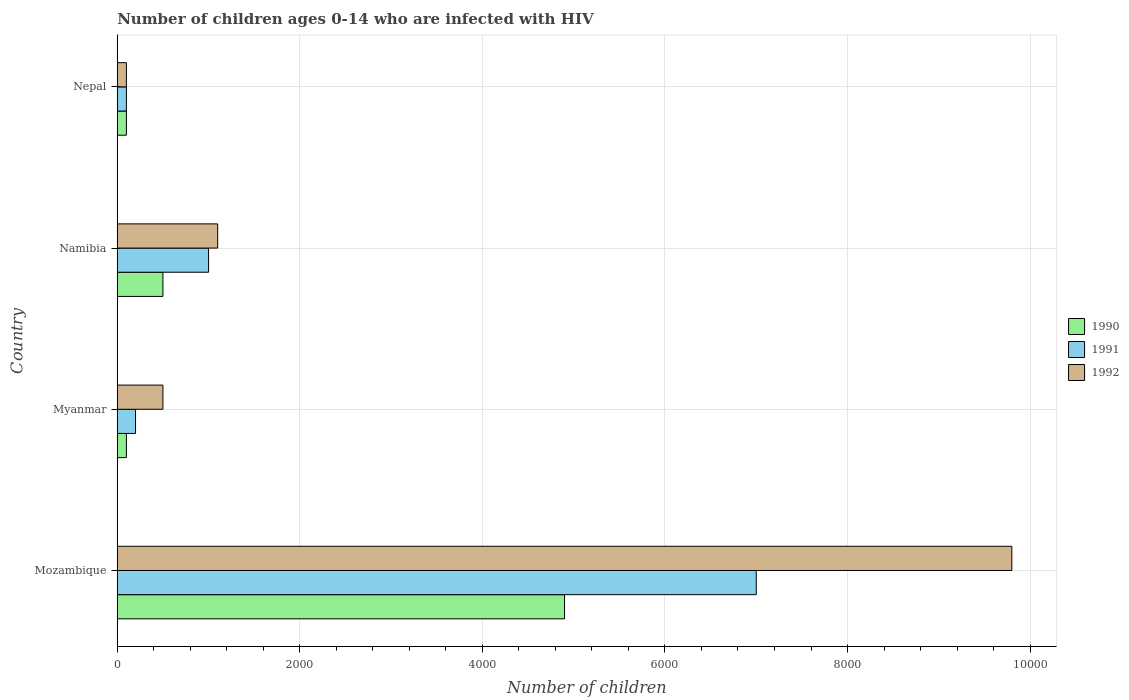How many different coloured bars are there?
Provide a short and direct response. 3. Are the number of bars on each tick of the Y-axis equal?
Your answer should be very brief. Yes. How many bars are there on the 4th tick from the top?
Offer a very short reply. 3. What is the label of the 3rd group of bars from the top?
Ensure brevity in your answer.  Myanmar. What is the number of HIV infected children in 1991 in Nepal?
Keep it short and to the point. 100. Across all countries, what is the maximum number of HIV infected children in 1991?
Provide a succinct answer. 7000. Across all countries, what is the minimum number of HIV infected children in 1991?
Provide a short and direct response. 100. In which country was the number of HIV infected children in 1992 maximum?
Provide a short and direct response. Mozambique. In which country was the number of HIV infected children in 1990 minimum?
Provide a succinct answer. Myanmar. What is the total number of HIV infected children in 1990 in the graph?
Your answer should be compact. 5600. What is the difference between the number of HIV infected children in 1992 in Mozambique and that in Namibia?
Ensure brevity in your answer.  8700. What is the difference between the number of HIV infected children in 1992 in Myanmar and the number of HIV infected children in 1991 in Nepal?
Offer a very short reply. 400. What is the average number of HIV infected children in 1991 per country?
Your answer should be very brief. 2075. What is the difference between the number of HIV infected children in 1992 and number of HIV infected children in 1991 in Nepal?
Your answer should be very brief. 0. In how many countries, is the number of HIV infected children in 1992 greater than 8400 ?
Provide a short and direct response. 1. What is the ratio of the number of HIV infected children in 1991 in Myanmar to that in Nepal?
Ensure brevity in your answer.  2. Is the number of HIV infected children in 1990 in Mozambique less than that in Nepal?
Your response must be concise. No. What is the difference between the highest and the second highest number of HIV infected children in 1992?
Keep it short and to the point. 8700. What is the difference between the highest and the lowest number of HIV infected children in 1990?
Your answer should be very brief. 4800. Is the sum of the number of HIV infected children in 1990 in Mozambique and Myanmar greater than the maximum number of HIV infected children in 1991 across all countries?
Keep it short and to the point. No. How many bars are there?
Offer a very short reply. 12. Are all the bars in the graph horizontal?
Your answer should be compact. Yes. How many countries are there in the graph?
Your answer should be compact. 4. What is the difference between two consecutive major ticks on the X-axis?
Offer a terse response. 2000. Are the values on the major ticks of X-axis written in scientific E-notation?
Your response must be concise. No. Where does the legend appear in the graph?
Provide a succinct answer. Center right. What is the title of the graph?
Your answer should be very brief. Number of children ages 0-14 who are infected with HIV. What is the label or title of the X-axis?
Offer a very short reply. Number of children. What is the label or title of the Y-axis?
Provide a succinct answer. Country. What is the Number of children in 1990 in Mozambique?
Make the answer very short. 4900. What is the Number of children of 1991 in Mozambique?
Make the answer very short. 7000. What is the Number of children of 1992 in Mozambique?
Your response must be concise. 9800. What is the Number of children in 1990 in Myanmar?
Your response must be concise. 100. What is the Number of children in 1990 in Namibia?
Ensure brevity in your answer.  500. What is the Number of children of 1992 in Namibia?
Your answer should be compact. 1100. What is the Number of children in 1991 in Nepal?
Offer a very short reply. 100. What is the Number of children in 1992 in Nepal?
Provide a succinct answer. 100. Across all countries, what is the maximum Number of children in 1990?
Your response must be concise. 4900. Across all countries, what is the maximum Number of children in 1991?
Your answer should be compact. 7000. Across all countries, what is the maximum Number of children in 1992?
Offer a terse response. 9800. Across all countries, what is the minimum Number of children in 1991?
Offer a terse response. 100. What is the total Number of children in 1990 in the graph?
Give a very brief answer. 5600. What is the total Number of children of 1991 in the graph?
Your answer should be compact. 8300. What is the total Number of children in 1992 in the graph?
Give a very brief answer. 1.15e+04. What is the difference between the Number of children of 1990 in Mozambique and that in Myanmar?
Your response must be concise. 4800. What is the difference between the Number of children of 1991 in Mozambique and that in Myanmar?
Your response must be concise. 6800. What is the difference between the Number of children in 1992 in Mozambique and that in Myanmar?
Your answer should be very brief. 9300. What is the difference between the Number of children of 1990 in Mozambique and that in Namibia?
Make the answer very short. 4400. What is the difference between the Number of children in 1991 in Mozambique and that in Namibia?
Make the answer very short. 6000. What is the difference between the Number of children in 1992 in Mozambique and that in Namibia?
Make the answer very short. 8700. What is the difference between the Number of children in 1990 in Mozambique and that in Nepal?
Ensure brevity in your answer.  4800. What is the difference between the Number of children in 1991 in Mozambique and that in Nepal?
Provide a short and direct response. 6900. What is the difference between the Number of children in 1992 in Mozambique and that in Nepal?
Offer a very short reply. 9700. What is the difference between the Number of children of 1990 in Myanmar and that in Namibia?
Give a very brief answer. -400. What is the difference between the Number of children in 1991 in Myanmar and that in Namibia?
Provide a short and direct response. -800. What is the difference between the Number of children of 1992 in Myanmar and that in Namibia?
Your answer should be very brief. -600. What is the difference between the Number of children of 1990 in Myanmar and that in Nepal?
Your response must be concise. 0. What is the difference between the Number of children of 1991 in Myanmar and that in Nepal?
Provide a short and direct response. 100. What is the difference between the Number of children in 1992 in Myanmar and that in Nepal?
Your answer should be very brief. 400. What is the difference between the Number of children of 1990 in Namibia and that in Nepal?
Give a very brief answer. 400. What is the difference between the Number of children of 1991 in Namibia and that in Nepal?
Your response must be concise. 900. What is the difference between the Number of children of 1992 in Namibia and that in Nepal?
Provide a short and direct response. 1000. What is the difference between the Number of children in 1990 in Mozambique and the Number of children in 1991 in Myanmar?
Keep it short and to the point. 4700. What is the difference between the Number of children of 1990 in Mozambique and the Number of children of 1992 in Myanmar?
Offer a terse response. 4400. What is the difference between the Number of children of 1991 in Mozambique and the Number of children of 1992 in Myanmar?
Your response must be concise. 6500. What is the difference between the Number of children of 1990 in Mozambique and the Number of children of 1991 in Namibia?
Your response must be concise. 3900. What is the difference between the Number of children of 1990 in Mozambique and the Number of children of 1992 in Namibia?
Your answer should be compact. 3800. What is the difference between the Number of children in 1991 in Mozambique and the Number of children in 1992 in Namibia?
Keep it short and to the point. 5900. What is the difference between the Number of children in 1990 in Mozambique and the Number of children in 1991 in Nepal?
Offer a very short reply. 4800. What is the difference between the Number of children in 1990 in Mozambique and the Number of children in 1992 in Nepal?
Give a very brief answer. 4800. What is the difference between the Number of children of 1991 in Mozambique and the Number of children of 1992 in Nepal?
Your response must be concise. 6900. What is the difference between the Number of children of 1990 in Myanmar and the Number of children of 1991 in Namibia?
Provide a short and direct response. -900. What is the difference between the Number of children of 1990 in Myanmar and the Number of children of 1992 in Namibia?
Offer a terse response. -1000. What is the difference between the Number of children of 1991 in Myanmar and the Number of children of 1992 in Namibia?
Your answer should be very brief. -900. What is the difference between the Number of children of 1990 in Myanmar and the Number of children of 1991 in Nepal?
Provide a short and direct response. 0. What is the difference between the Number of children in 1991 in Myanmar and the Number of children in 1992 in Nepal?
Your response must be concise. 100. What is the difference between the Number of children of 1990 in Namibia and the Number of children of 1992 in Nepal?
Your answer should be very brief. 400. What is the difference between the Number of children of 1991 in Namibia and the Number of children of 1992 in Nepal?
Give a very brief answer. 900. What is the average Number of children of 1990 per country?
Give a very brief answer. 1400. What is the average Number of children of 1991 per country?
Give a very brief answer. 2075. What is the average Number of children in 1992 per country?
Keep it short and to the point. 2875. What is the difference between the Number of children in 1990 and Number of children in 1991 in Mozambique?
Give a very brief answer. -2100. What is the difference between the Number of children in 1990 and Number of children in 1992 in Mozambique?
Your answer should be very brief. -4900. What is the difference between the Number of children of 1991 and Number of children of 1992 in Mozambique?
Provide a short and direct response. -2800. What is the difference between the Number of children in 1990 and Number of children in 1991 in Myanmar?
Your answer should be compact. -100. What is the difference between the Number of children in 1990 and Number of children in 1992 in Myanmar?
Offer a terse response. -400. What is the difference between the Number of children of 1991 and Number of children of 1992 in Myanmar?
Offer a very short reply. -300. What is the difference between the Number of children in 1990 and Number of children in 1991 in Namibia?
Offer a terse response. -500. What is the difference between the Number of children of 1990 and Number of children of 1992 in Namibia?
Offer a very short reply. -600. What is the difference between the Number of children of 1991 and Number of children of 1992 in Namibia?
Offer a terse response. -100. What is the difference between the Number of children in 1990 and Number of children in 1991 in Nepal?
Provide a succinct answer. 0. What is the ratio of the Number of children of 1991 in Mozambique to that in Myanmar?
Give a very brief answer. 35. What is the ratio of the Number of children in 1992 in Mozambique to that in Myanmar?
Provide a short and direct response. 19.6. What is the ratio of the Number of children in 1990 in Mozambique to that in Namibia?
Provide a short and direct response. 9.8. What is the ratio of the Number of children of 1991 in Mozambique to that in Namibia?
Give a very brief answer. 7. What is the ratio of the Number of children in 1992 in Mozambique to that in Namibia?
Provide a short and direct response. 8.91. What is the ratio of the Number of children in 1990 in Mozambique to that in Nepal?
Offer a terse response. 49. What is the ratio of the Number of children of 1992 in Mozambique to that in Nepal?
Offer a very short reply. 98. What is the ratio of the Number of children of 1990 in Myanmar to that in Namibia?
Ensure brevity in your answer.  0.2. What is the ratio of the Number of children in 1991 in Myanmar to that in Namibia?
Offer a very short reply. 0.2. What is the ratio of the Number of children of 1992 in Myanmar to that in Namibia?
Your response must be concise. 0.45. What is the ratio of the Number of children in 1991 in Myanmar to that in Nepal?
Make the answer very short. 2. What is the difference between the highest and the second highest Number of children of 1990?
Offer a terse response. 4400. What is the difference between the highest and the second highest Number of children in 1991?
Your response must be concise. 6000. What is the difference between the highest and the second highest Number of children of 1992?
Offer a very short reply. 8700. What is the difference between the highest and the lowest Number of children in 1990?
Your answer should be compact. 4800. What is the difference between the highest and the lowest Number of children in 1991?
Ensure brevity in your answer.  6900. What is the difference between the highest and the lowest Number of children of 1992?
Ensure brevity in your answer.  9700. 